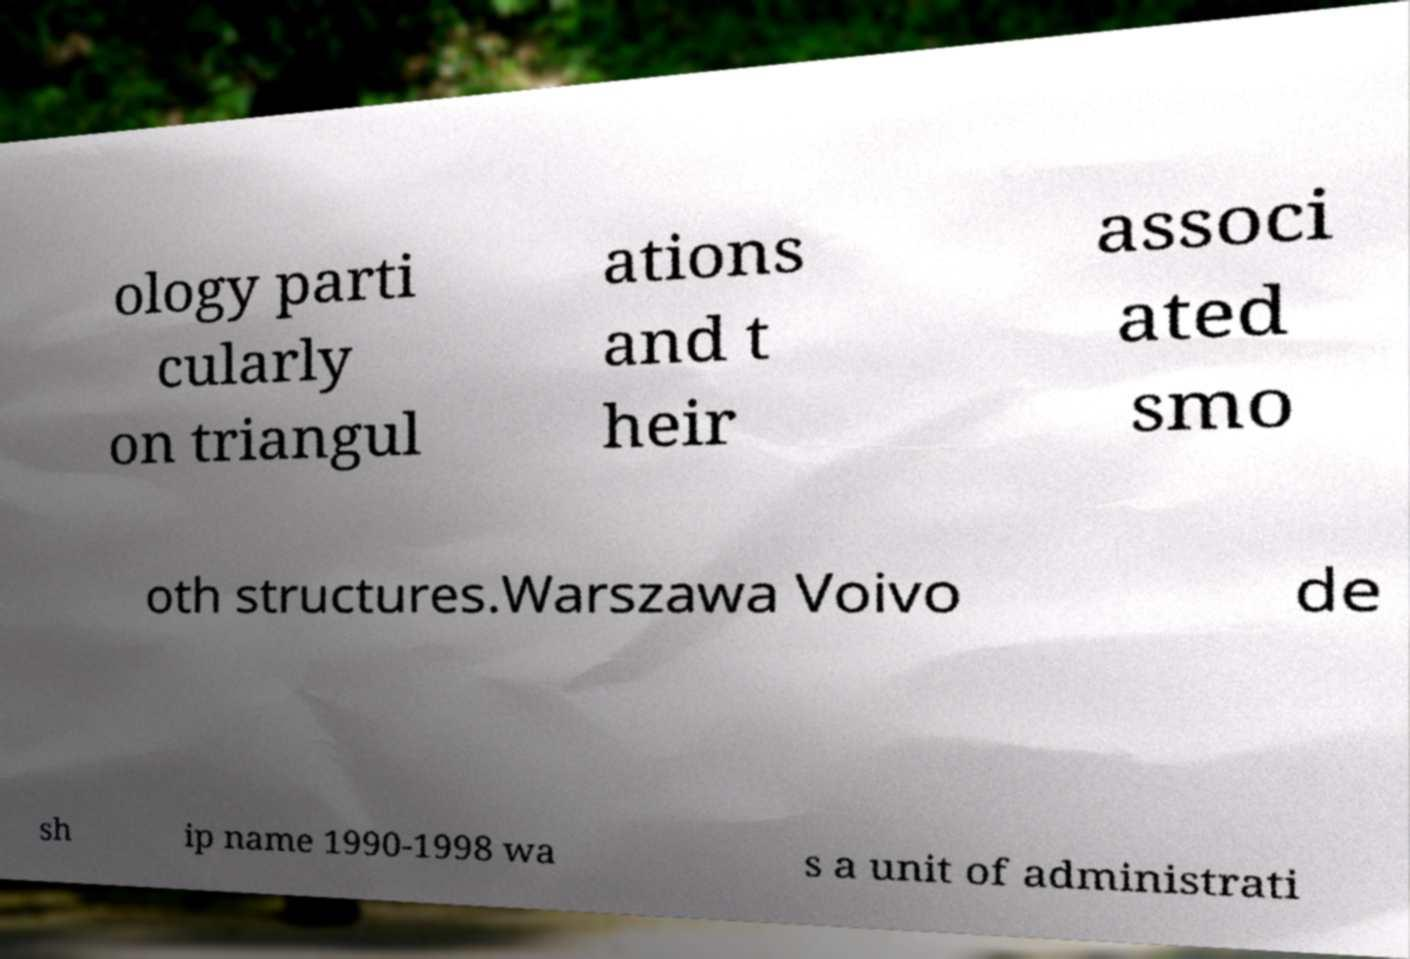Please identify and transcribe the text found in this image. ology parti cularly on triangul ations and t heir associ ated smo oth structures.Warszawa Voivo de sh ip name 1990-1998 wa s a unit of administrati 